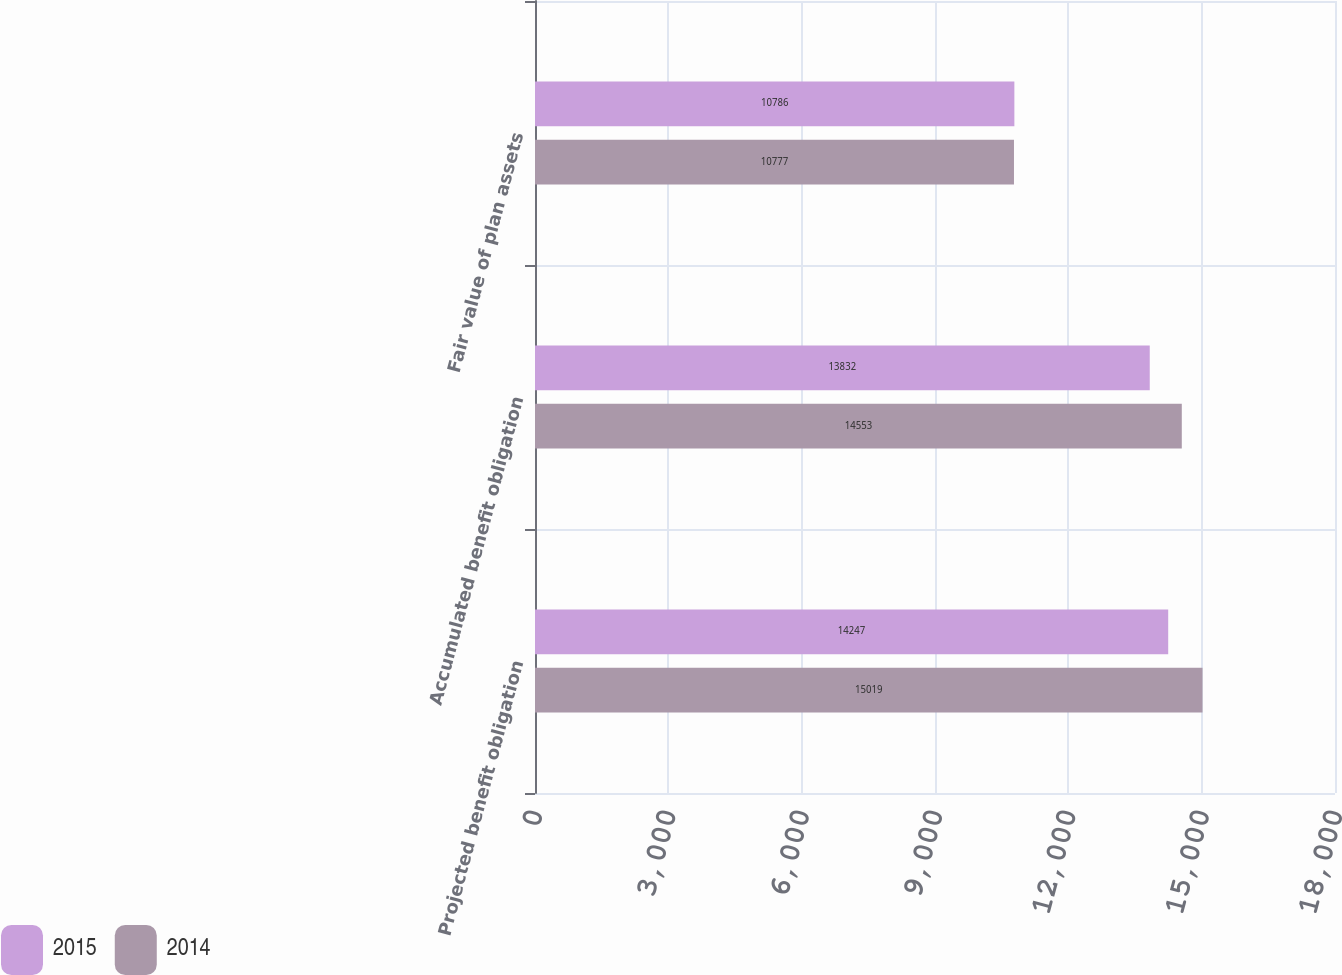<chart> <loc_0><loc_0><loc_500><loc_500><stacked_bar_chart><ecel><fcel>Projected benefit obligation<fcel>Accumulated benefit obligation<fcel>Fair value of plan assets<nl><fcel>2015<fcel>14247<fcel>13832<fcel>10786<nl><fcel>2014<fcel>15019<fcel>14553<fcel>10777<nl></chart> 